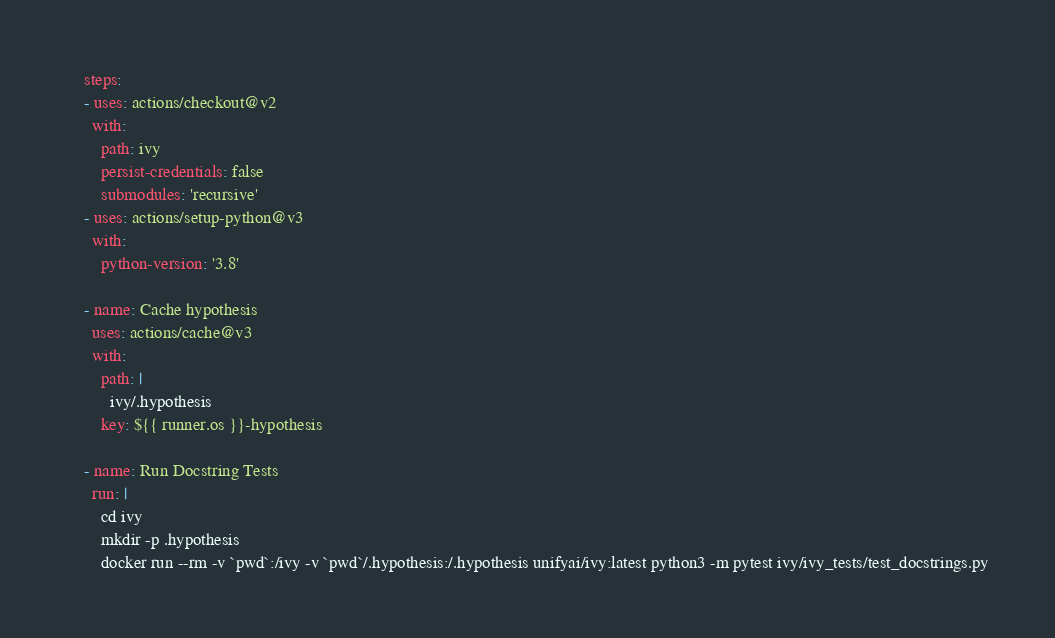Convert code to text. <code><loc_0><loc_0><loc_500><loc_500><_YAML_>    steps:
    - uses: actions/checkout@v2
      with:
        path: ivy
        persist-credentials: false
        submodules: 'recursive'
    - uses: actions/setup-python@v3
      with:
        python-version: '3.8'

    - name: Cache hypothesis
      uses: actions/cache@v3
      with:
        path: |
          ivy/.hypothesis
        key: ${{ runner.os }}-hypothesis

    - name: Run Docstring Tests
      run: |
        cd ivy
        mkdir -p .hypothesis
        docker run --rm -v `pwd`:/ivy -v `pwd`/.hypothesis:/.hypothesis unifyai/ivy:latest python3 -m pytest ivy/ivy_tests/test_docstrings.py
</code> 